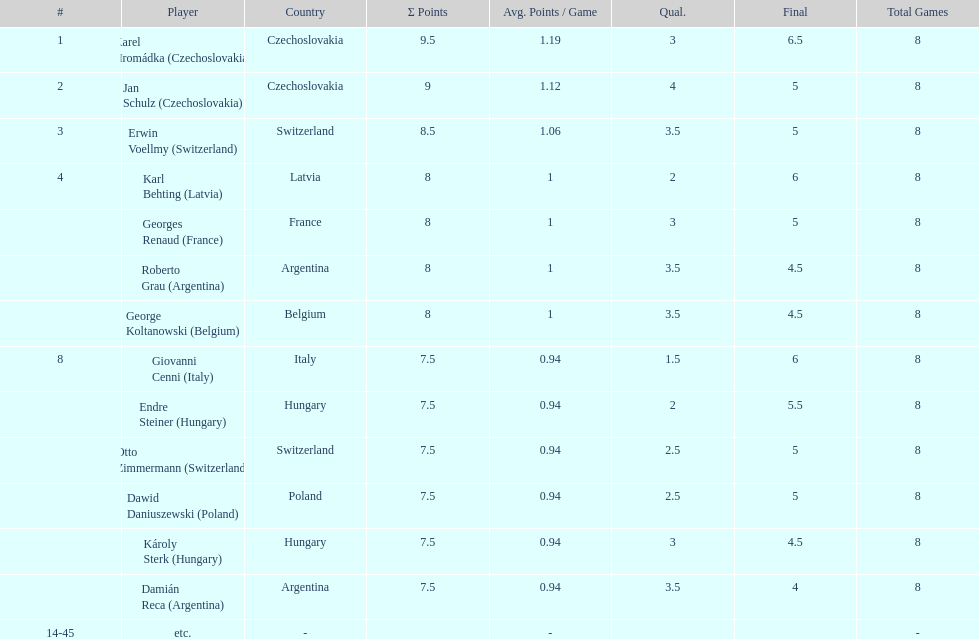Who was the player with the most points scored? Karel Hromádka. 